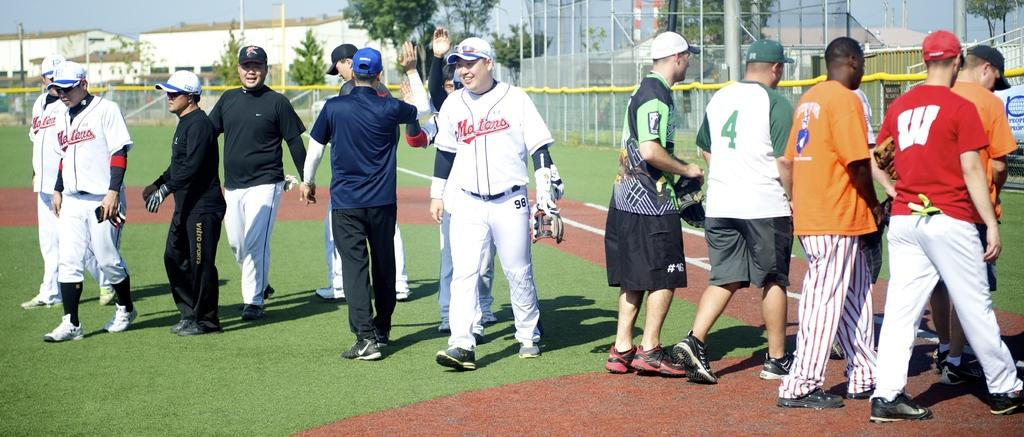<image>
Summarize the visual content of the image. a few players on a field one with the number 4 